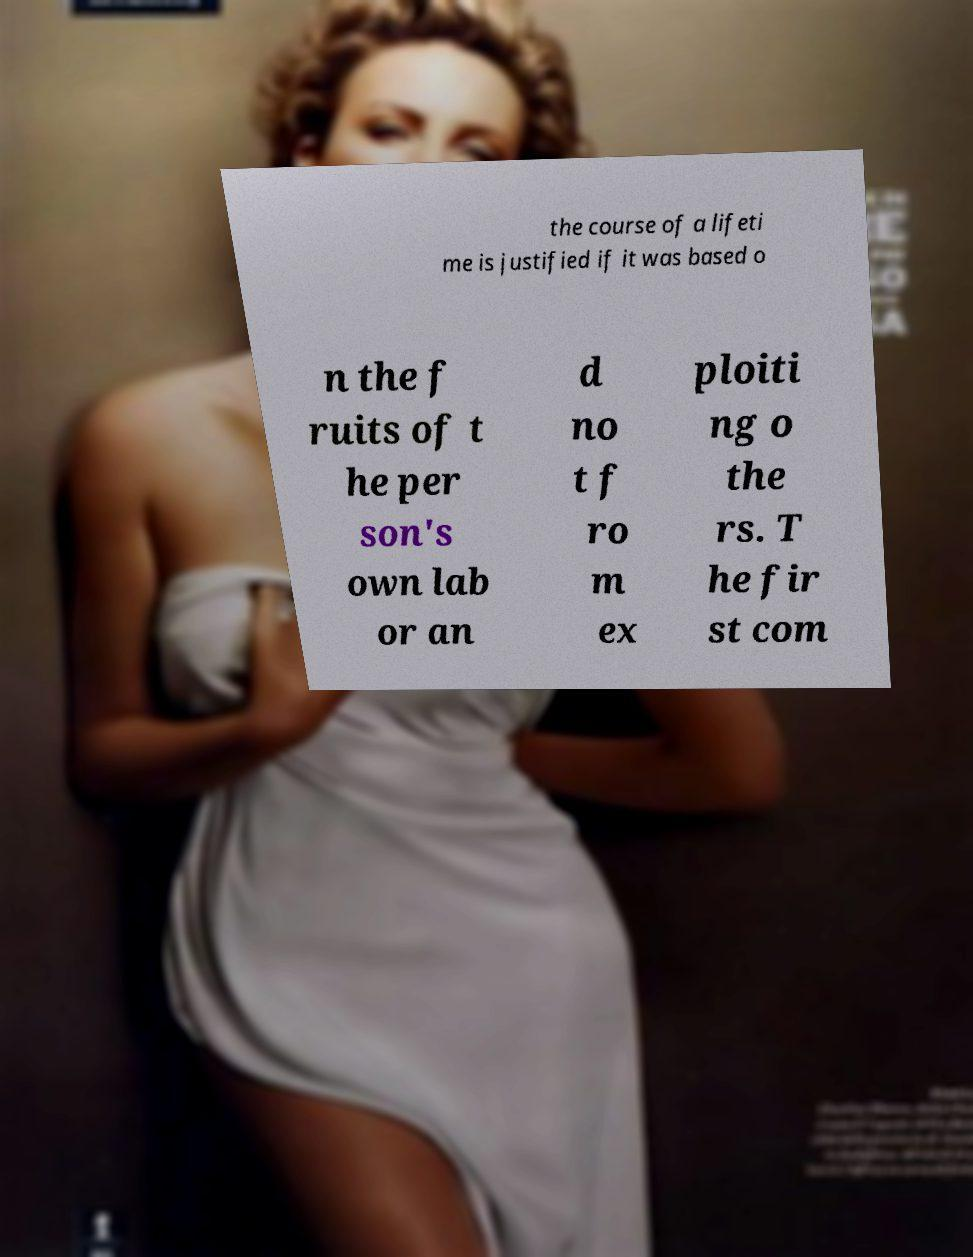Could you extract and type out the text from this image? the course of a lifeti me is justified if it was based o n the f ruits of t he per son's own lab or an d no t f ro m ex ploiti ng o the rs. T he fir st com 